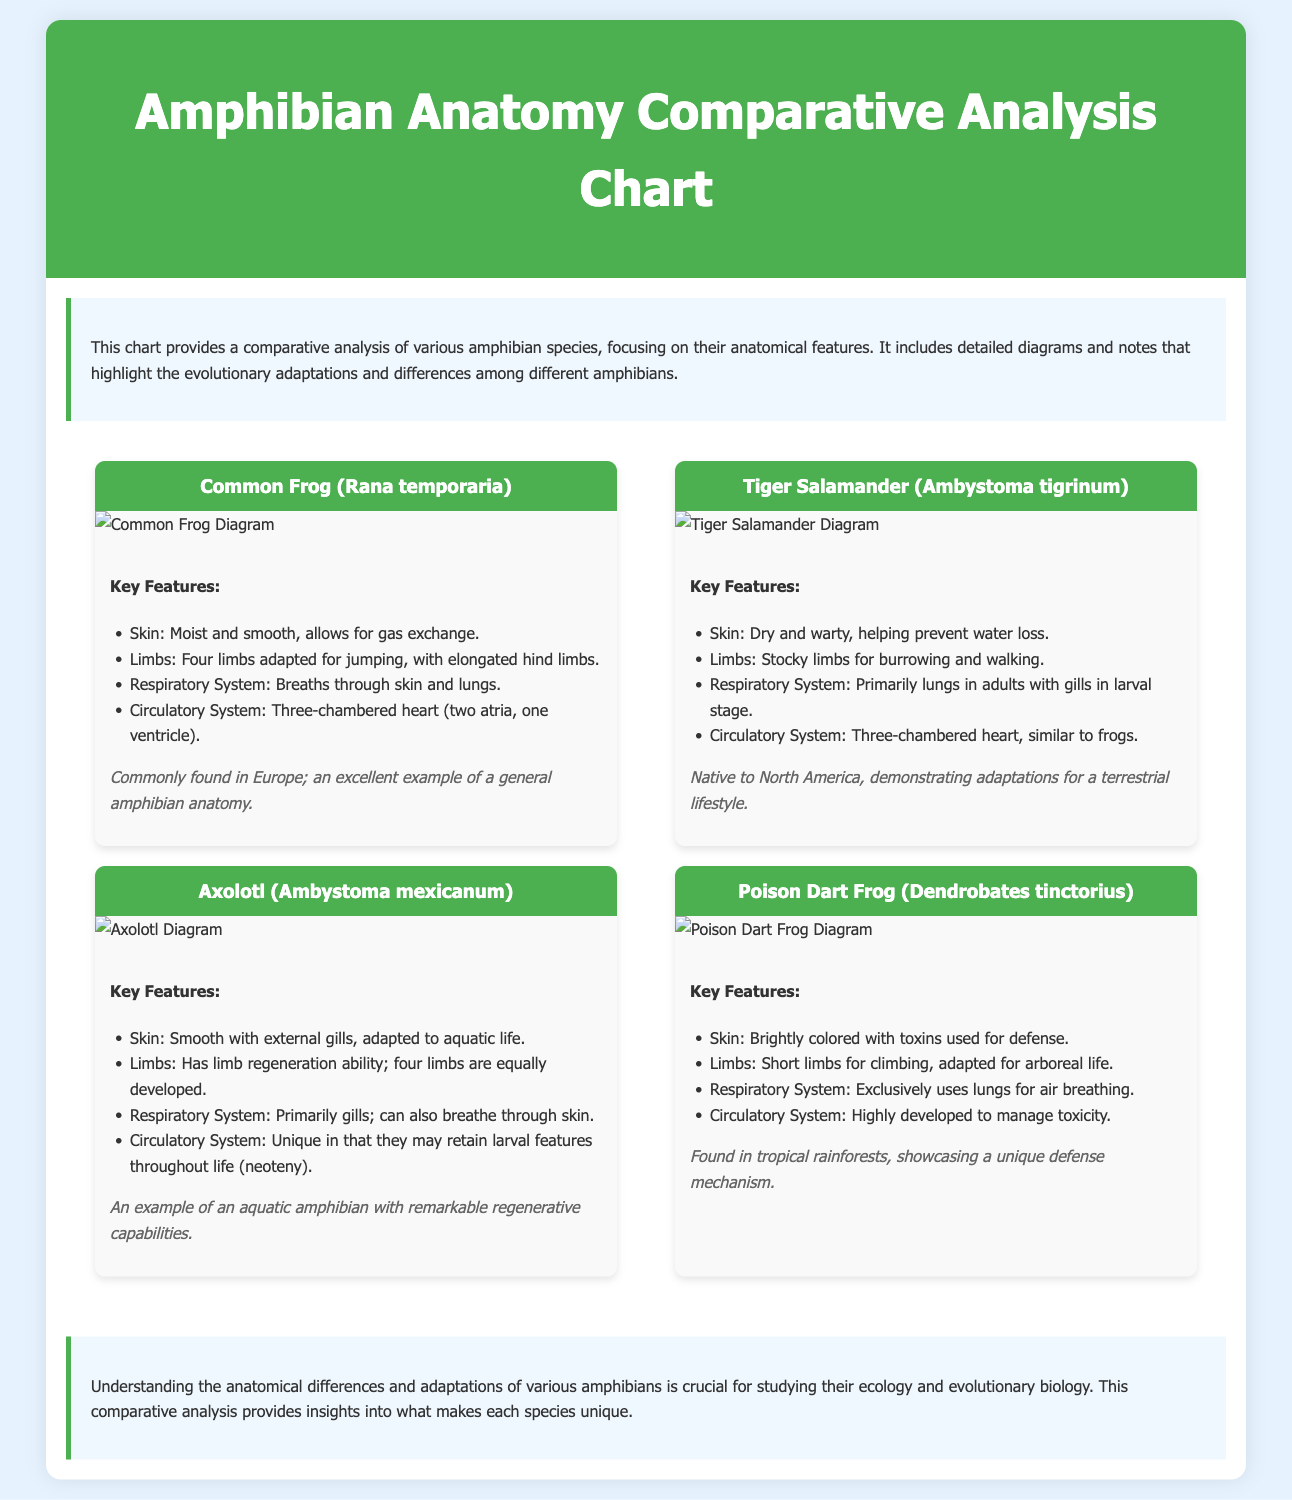what is the title of the document? The title of the document is provided in the header section, which summarizes its content about amphibian anatomy.
Answer: Amphibian Anatomy Comparative Analysis Chart how many species are compared in the chart? The document lists four species in the comparative analysis section.
Answer: Four which amphibian has a three-chambered heart? This anatomical feature is mentioned for multiple amphibians, indicating that both frogs and salamanders share this characteristic.
Answer: Common Frog, Tiger Salamander what is a unique feature of the Axolotl? The Axolotl is noted for its unique ability to retain larval features throughout life, also known as neoteny.
Answer: Neoteny what type of skin does the Poison Dart Frog have? The document describes the skin of the Poison Dart Frog as brightly colored with toxins for defense.
Answer: Brightly colored with toxins which amphibian is primarily aquatic? Among the species listed, the Axolotl is specifically highlighted as an aquatic amphibian.
Answer: Axolotl what adaptations are noted for Tiger Salamander's limbs? The document states that Tiger Salamander has stocky limbs adapted for burrowing and walking.
Answer: Stocky limbs for burrowing and walking how does the skin of the Common Frog assist in respiration? The Common Frog's skin is described as moist and smooth, allowing for gas exchange.
Answer: Allows for gas exchange 